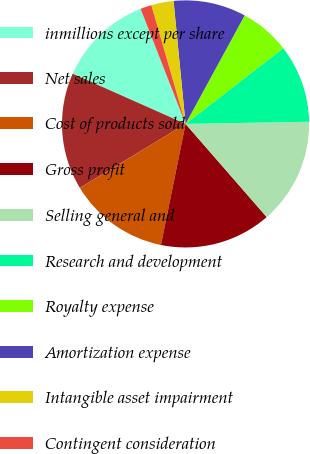<chart> <loc_0><loc_0><loc_500><loc_500><pie_chart><fcel>inmillions except per share<fcel>Net sales<fcel>Cost of products sold<fcel>Gross profit<fcel>Selling general and<fcel>Research and development<fcel>Royalty expense<fcel>Amortization expense<fcel>Intangible asset impairment<fcel>Contingent consideration<nl><fcel>12.41%<fcel>15.33%<fcel>13.14%<fcel>14.6%<fcel>13.87%<fcel>10.22%<fcel>6.57%<fcel>9.49%<fcel>2.92%<fcel>1.46%<nl></chart> 